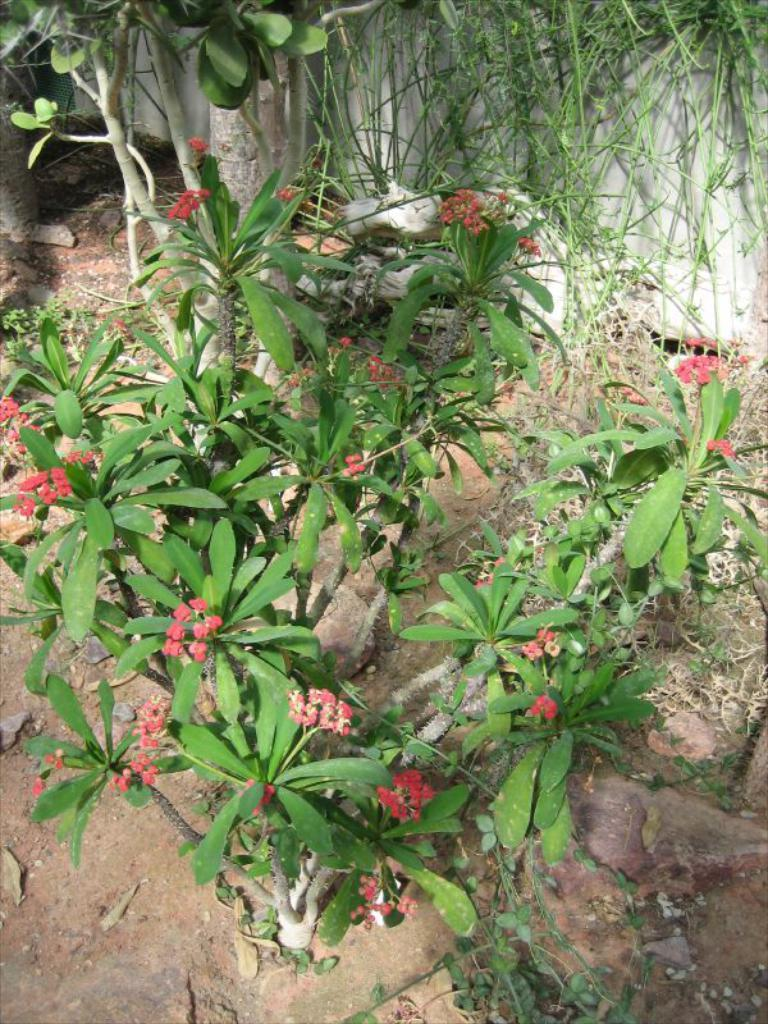What type of flowers can be seen on a plant in the image? There are red color flowers on a plant in the image. What other types of plants are present in the image? There are different types of plants in the image. What is at the bottom of the image? There is mud at the bottom of the image. What other elements can be seen in the image? There are stones in the image. What is visible in the background of the image? There is a wall in the background of the image. What type of dress is the whistle wearing in the image? There is no whistle or dress present in the image. 